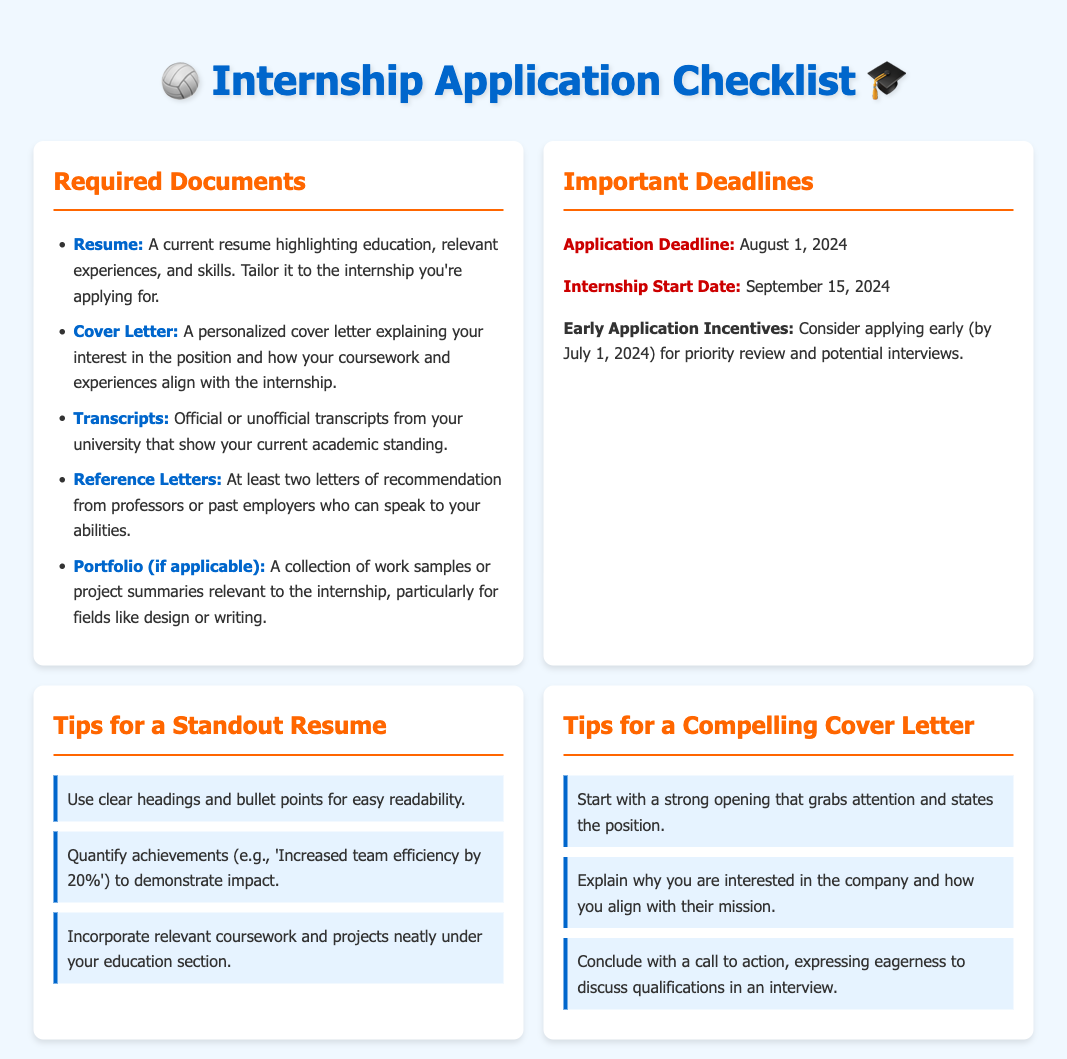What are the required documents for the internship application? The required documents can be found in the "Required Documents" section of the checklist.
Answer: Resume, Cover Letter, Transcripts, Reference Letters, Portfolio (if applicable) What is the application deadline? The application deadline is listed in the "Important Deadlines" section.
Answer: August 1, 2024 What should be included in the cover letter? The elements that should be included in the cover letter are mentioned in the "Tips for a Compelling Cover Letter" section.
Answer: Interest in the company and alignment with their mission What is one tip for a standout resume? Tips for a standout resume are provided in the respective section.
Answer: Use clear headings and bullet points for easy readability When does the internship start? The start date for the internship is provided in the "Important Deadlines" section.
Answer: September 15, 2024 What should be quantified in the resume? This is specified in the tips provided for the resume.
Answer: Achievements What is a suggested deadline for early application? The early application deadline is noted in the "Important Deadlines" section.
Answer: July 1, 2024 How many reference letters are required? The requirement for reference letters is stated in the "Required Documents" section.
Answer: At least two 